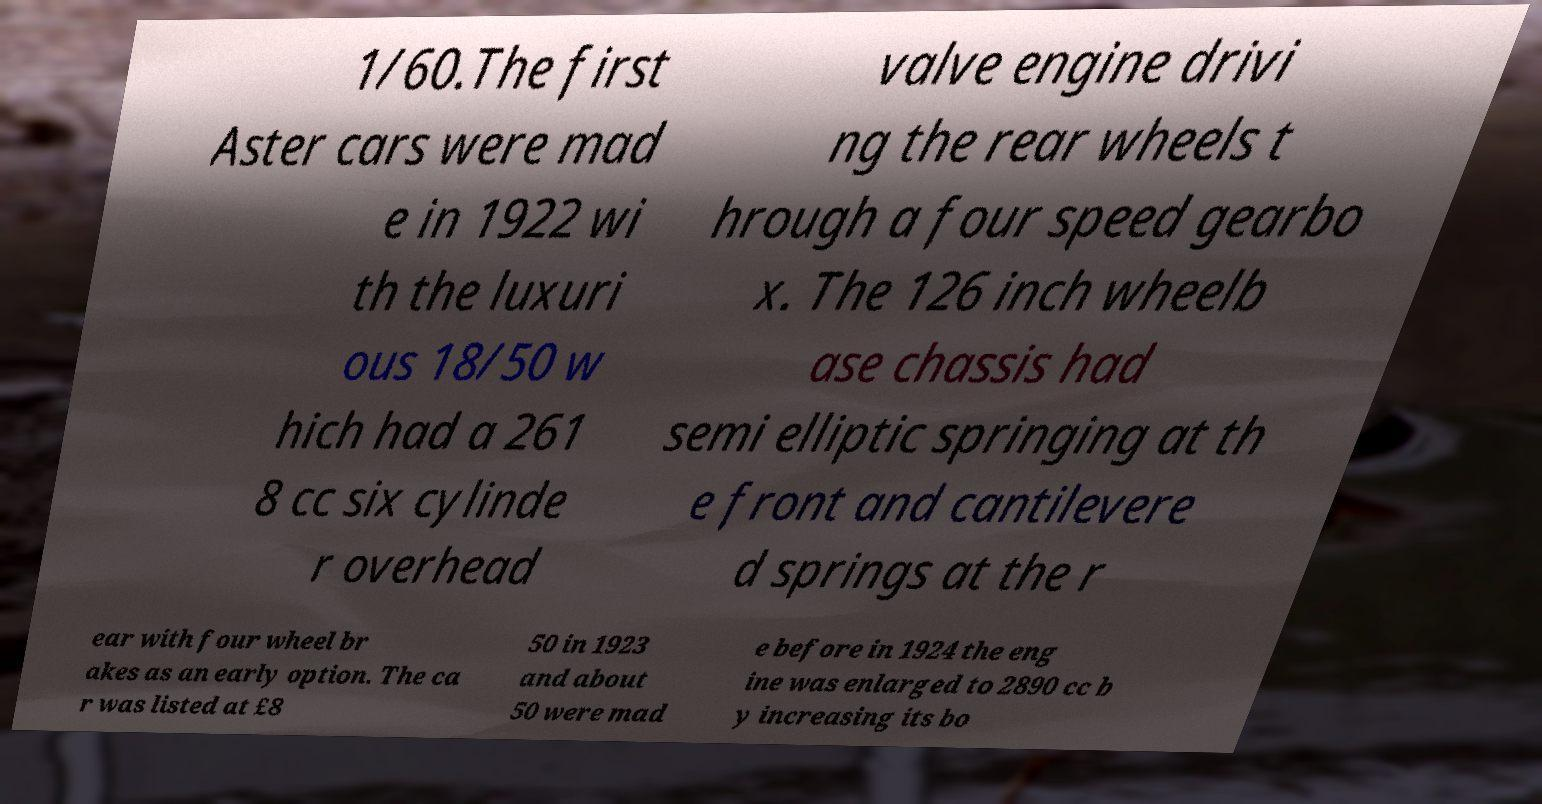Please identify and transcribe the text found in this image. 1/60.The first Aster cars were mad e in 1922 wi th the luxuri ous 18/50 w hich had a 261 8 cc six cylinde r overhead valve engine drivi ng the rear wheels t hrough a four speed gearbo x. The 126 inch wheelb ase chassis had semi elliptic springing at th e front and cantilevere d springs at the r ear with four wheel br akes as an early option. The ca r was listed at £8 50 in 1923 and about 50 were mad e before in 1924 the eng ine was enlarged to 2890 cc b y increasing its bo 